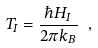Convert formula to latex. <formula><loc_0><loc_0><loc_500><loc_500>T _ { I } = \frac { \hbar { H } _ { I } } { 2 \pi k _ { B } } \ ,</formula> 